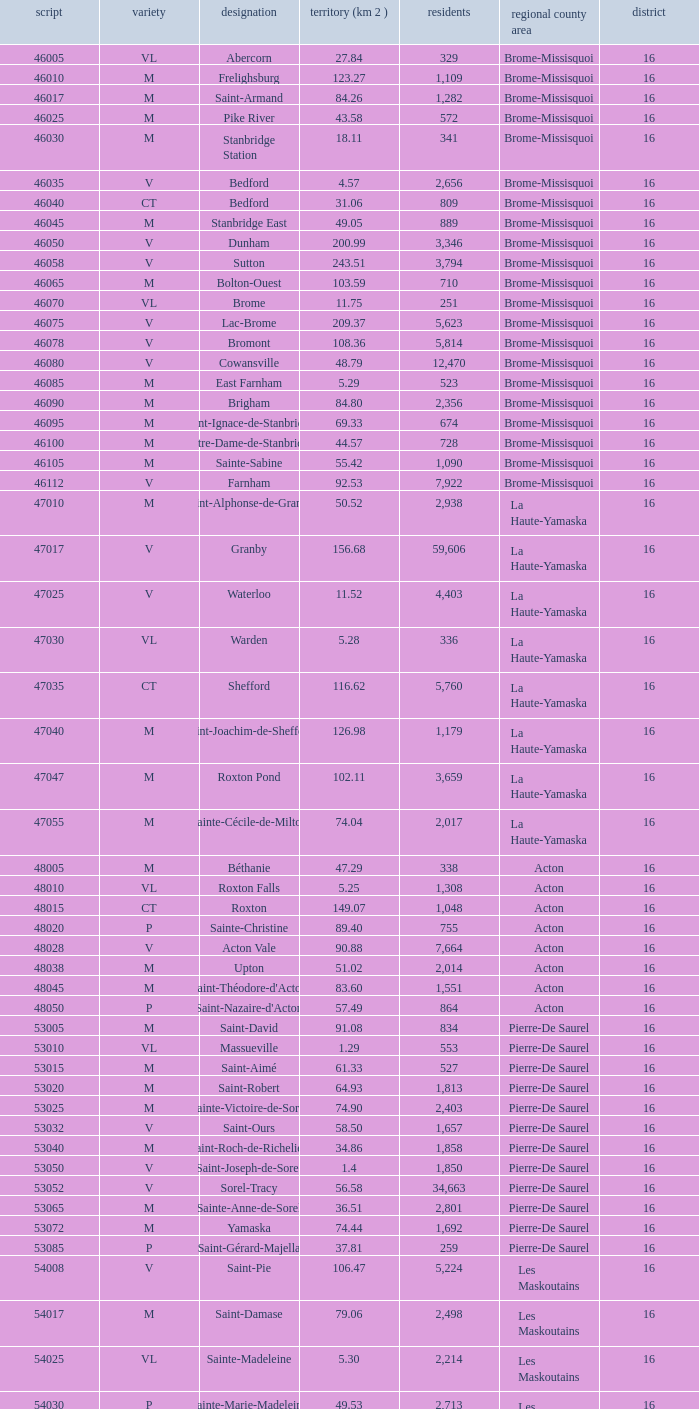What is the code for a Le Haut-Saint-Laurent municipality that has 16 or more regions? None. 